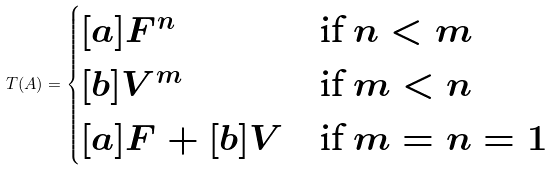<formula> <loc_0><loc_0><loc_500><loc_500>\L T ( A ) = \begin{cases} [ a ] F ^ { n } & \text {if } n < m \\ [ b ] V ^ { m } & \text {if } m < n \\ [ a ] F + [ b ] V & \text {if } m = n = 1 \end{cases}</formula> 